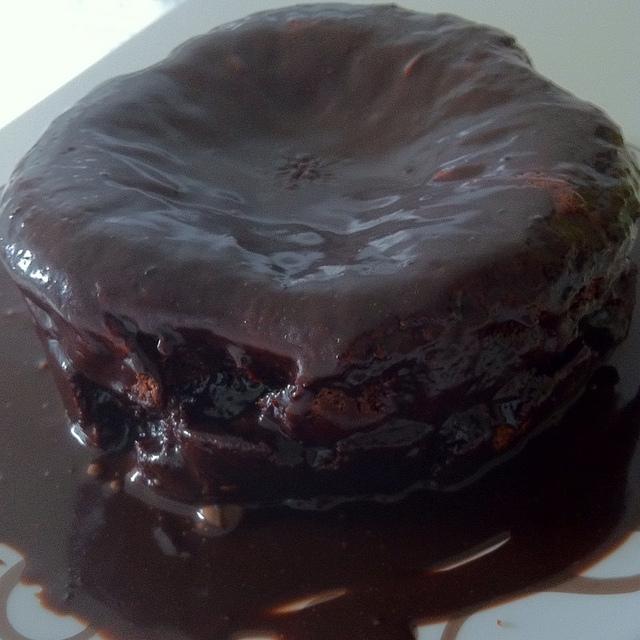Do you eat this?
Short answer required. Yes. Is this topped with frosting or glaze?
Be succinct. Glaze. Where is the chocolate syrup?
Give a very brief answer. On cake. 